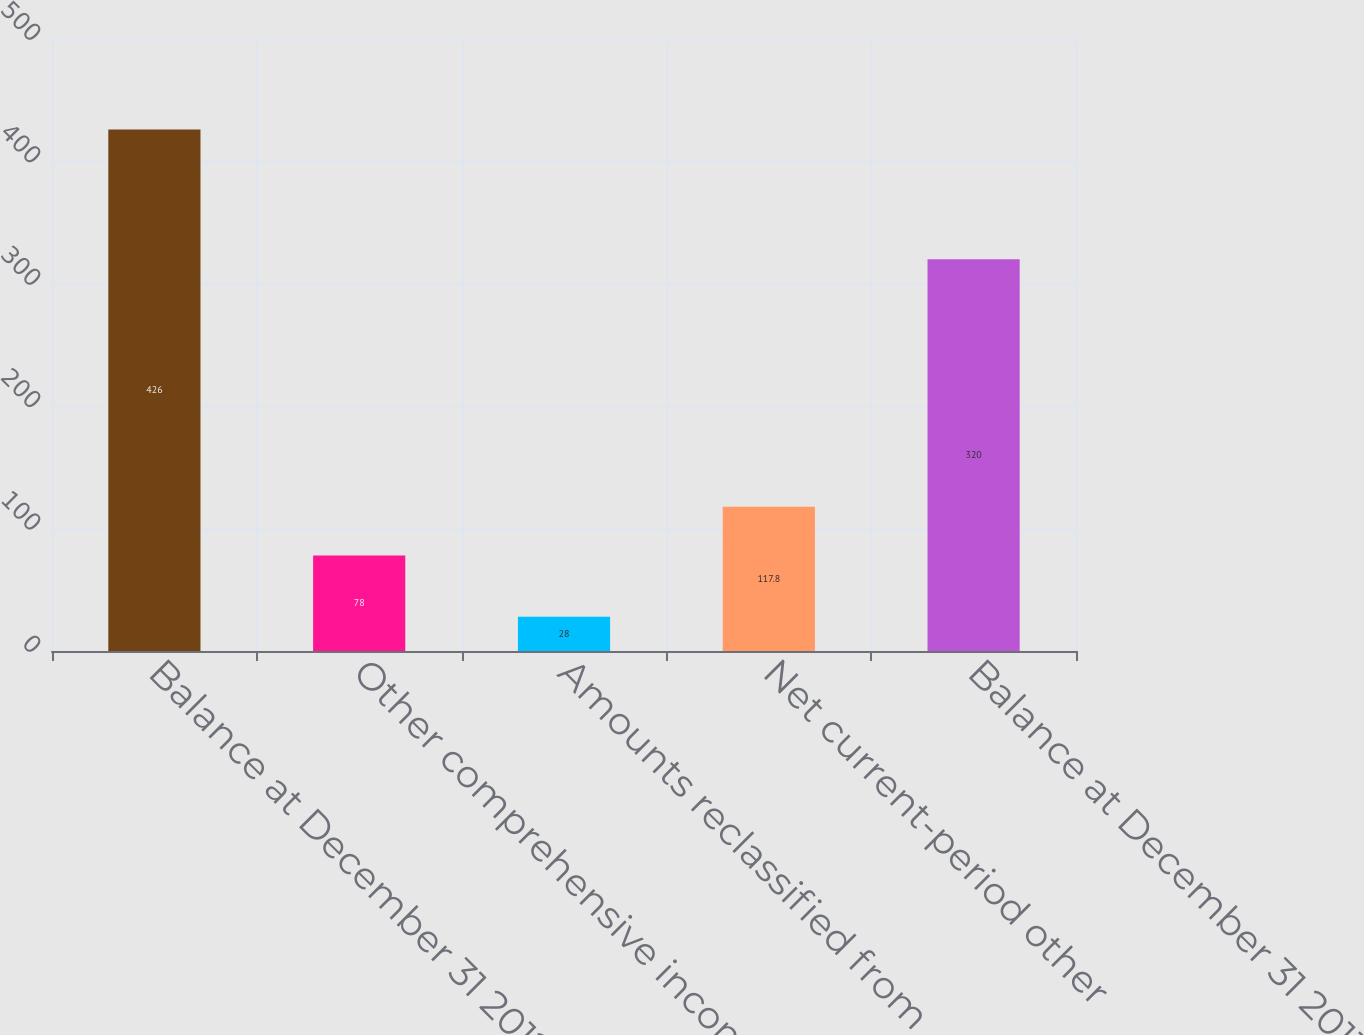Convert chart. <chart><loc_0><loc_0><loc_500><loc_500><bar_chart><fcel>Balance at December 31 2012<fcel>Other comprehensive income<fcel>Amounts reclassified from<fcel>Net current-period other<fcel>Balance at December 31 2013<nl><fcel>426<fcel>78<fcel>28<fcel>117.8<fcel>320<nl></chart> 